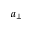Convert formula to latex. <formula><loc_0><loc_0><loc_500><loc_500>a _ { \perp }</formula> 